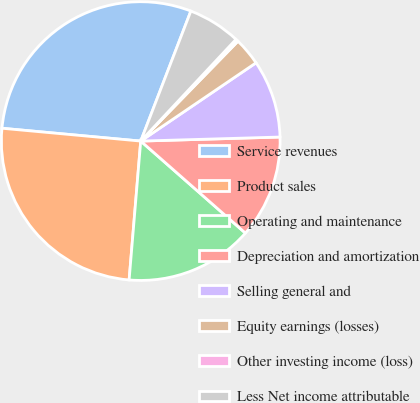Convert chart. <chart><loc_0><loc_0><loc_500><loc_500><pie_chart><fcel>Service revenues<fcel>Product sales<fcel>Operating and maintenance<fcel>Depreciation and amortization<fcel>Selling general and<fcel>Equity earnings (losses)<fcel>Other investing income (loss)<fcel>Less Net income attributable<nl><fcel>29.39%<fcel>25.14%<fcel>14.85%<fcel>11.94%<fcel>9.03%<fcel>3.22%<fcel>0.31%<fcel>6.12%<nl></chart> 